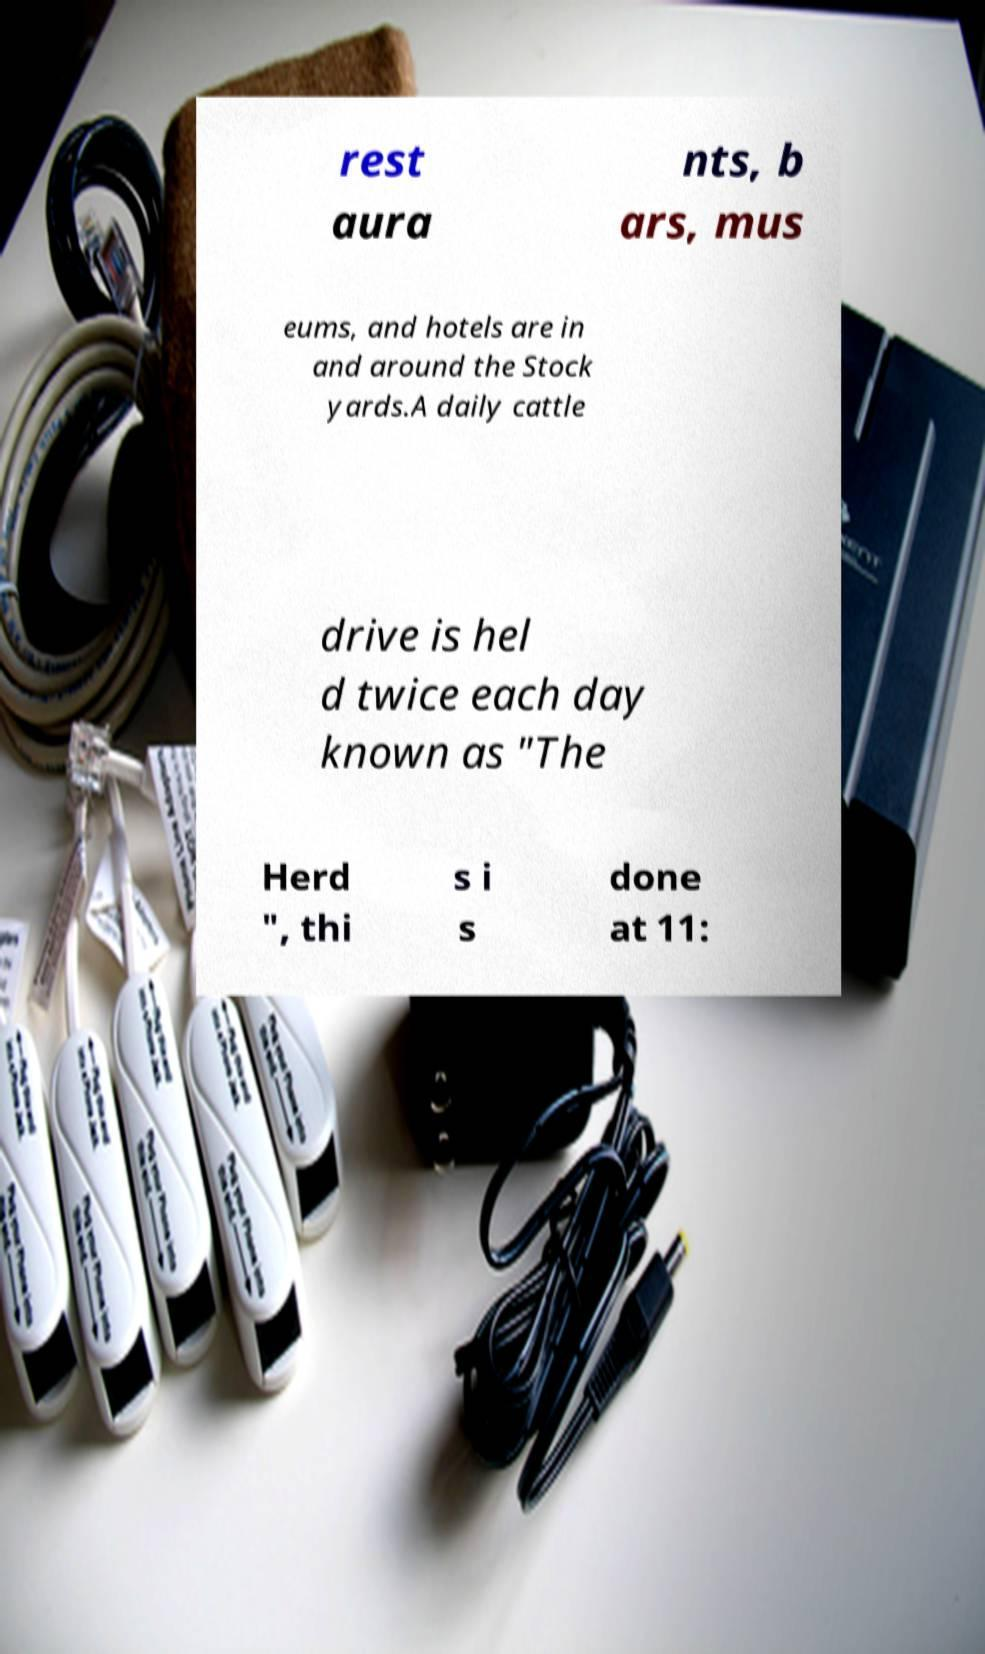Could you extract and type out the text from this image? rest aura nts, b ars, mus eums, and hotels are in and around the Stock yards.A daily cattle drive is hel d twice each day known as "The Herd ", thi s i s done at 11: 